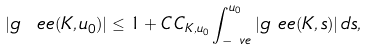<formula> <loc_0><loc_0><loc_500><loc_500>| g \ e e ( K , u _ { 0 } ) | & \leq 1 + C \, C _ { K , u _ { 0 } } \int _ { - \ v e } ^ { u _ { 0 } } | g \ e e ( K , s ) | \, d s ,</formula> 